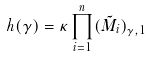<formula> <loc_0><loc_0><loc_500><loc_500>h ( \gamma ) = \kappa \prod _ { i = 1 } ^ { n } ( \tilde { M } _ { i } ) _ { \gamma , 1 }</formula> 